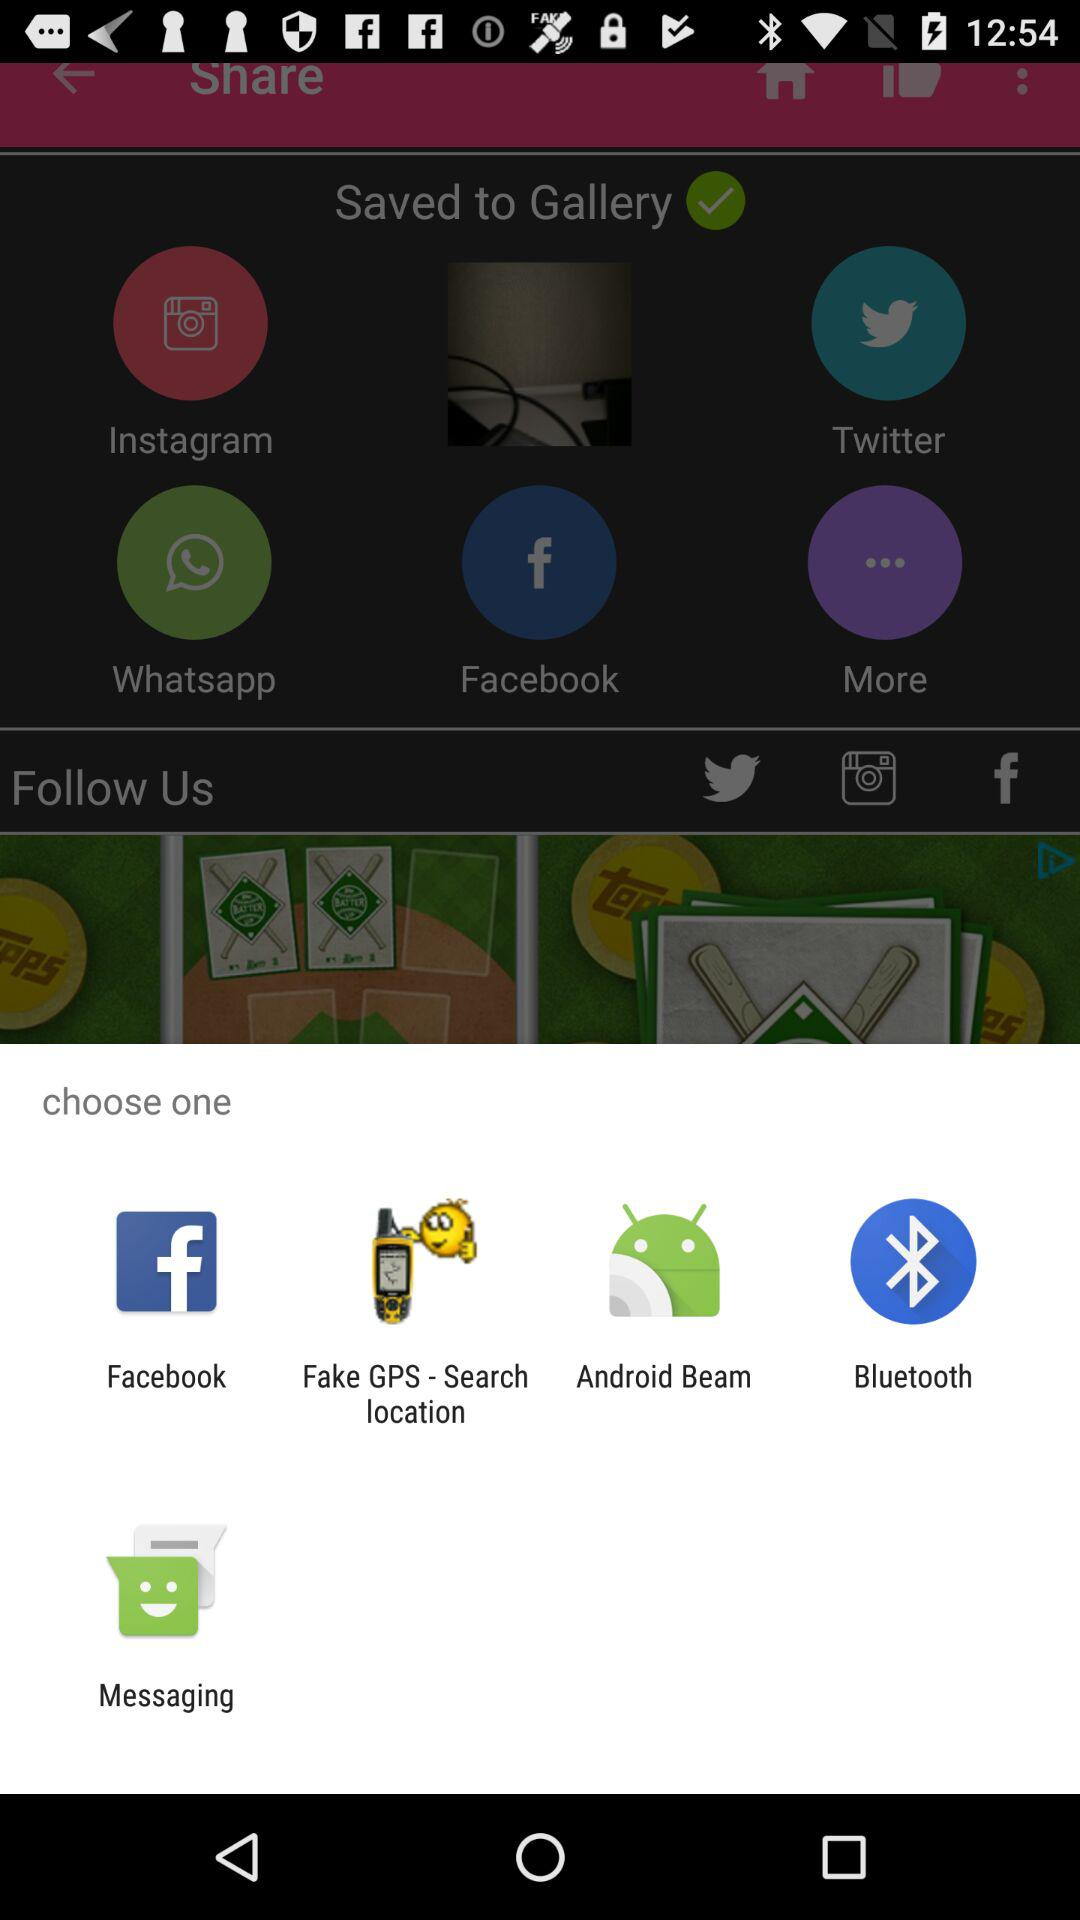What applications can be chosen from? The applications that can be chosen from are "Facebook", "Fake GPS - Search location", "Android Beam", "Bluetooth" and "Messaging". 